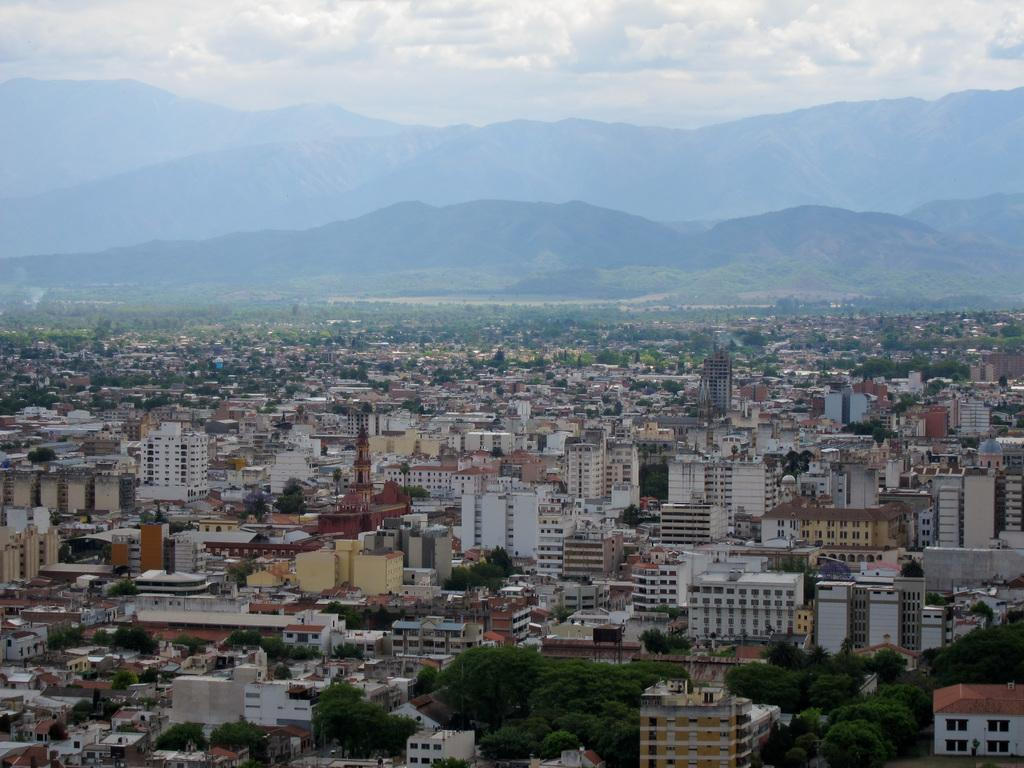What is the main subject in the middle of the picture? There is a building in the middle of the picture. What can be seen in the background of the picture? There are hills and clouds in the sky in the background of the picture. How many pets can be seen in the picture? There are no pets visible in the picture; it features a building, hills, and clouds. 